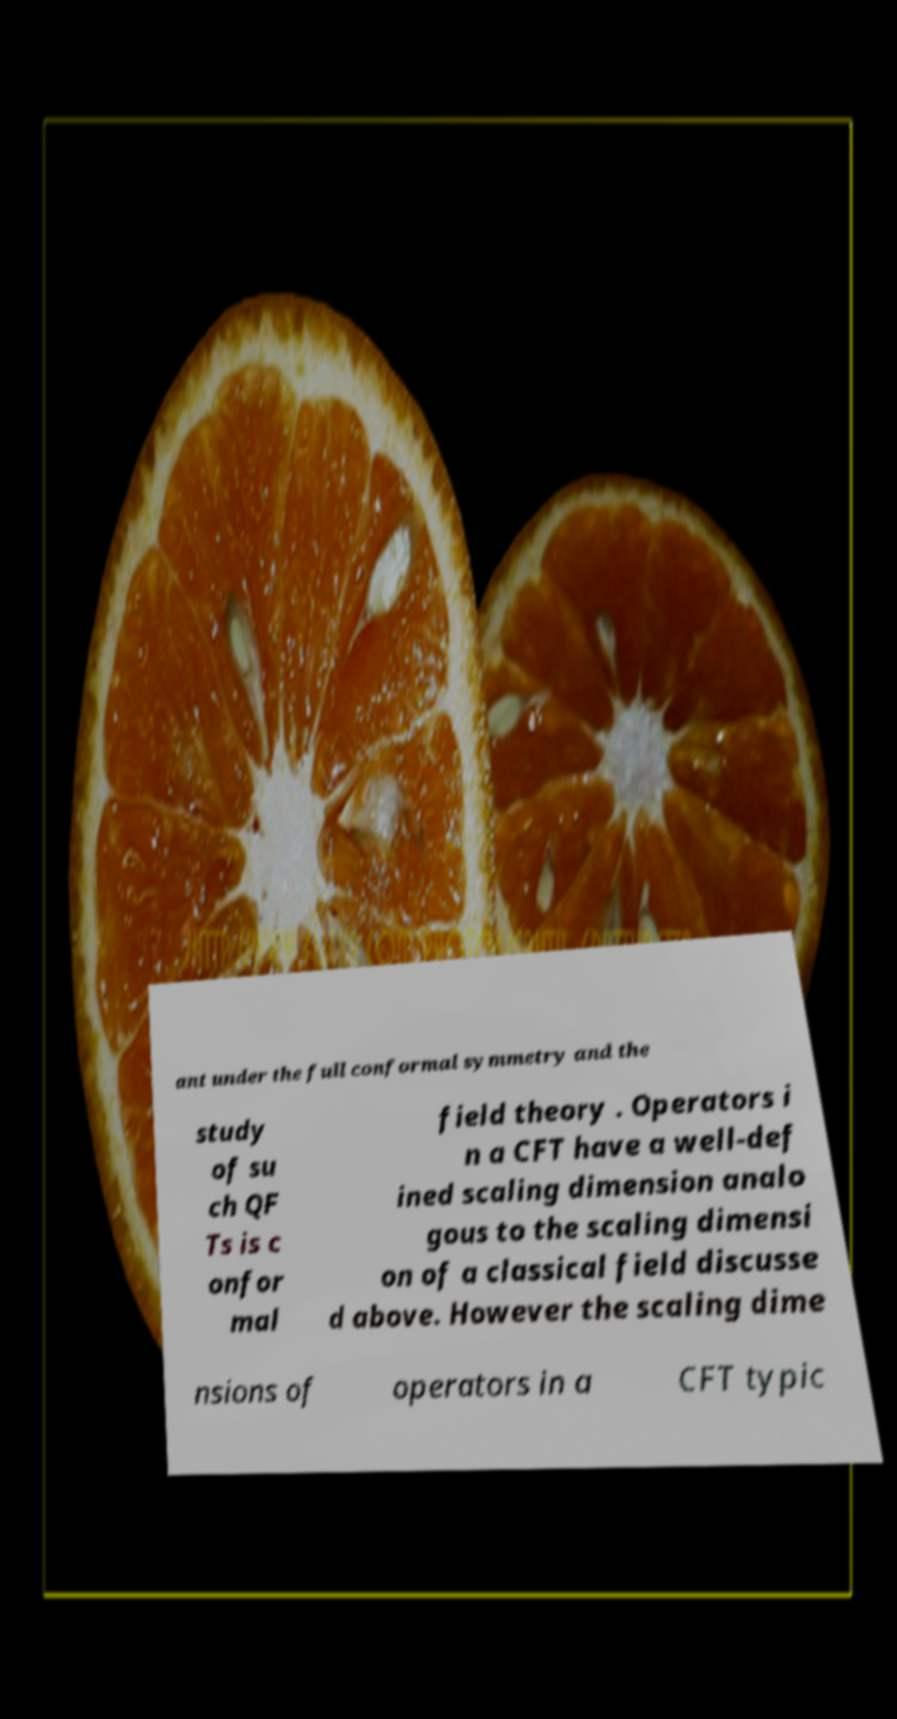Please identify and transcribe the text found in this image. ant under the full conformal symmetry and the study of su ch QF Ts is c onfor mal field theory . Operators i n a CFT have a well-def ined scaling dimension analo gous to the scaling dimensi on of a classical field discusse d above. However the scaling dime nsions of operators in a CFT typic 